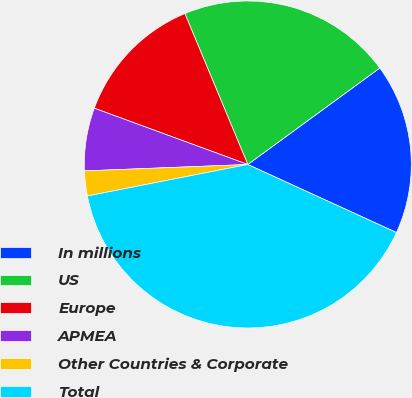Convert chart. <chart><loc_0><loc_0><loc_500><loc_500><pie_chart><fcel>In millions<fcel>US<fcel>Europe<fcel>APMEA<fcel>Other Countries & Corporate<fcel>Total<nl><fcel>16.88%<fcel>21.24%<fcel>13.12%<fcel>6.22%<fcel>2.46%<fcel>40.08%<nl></chart> 